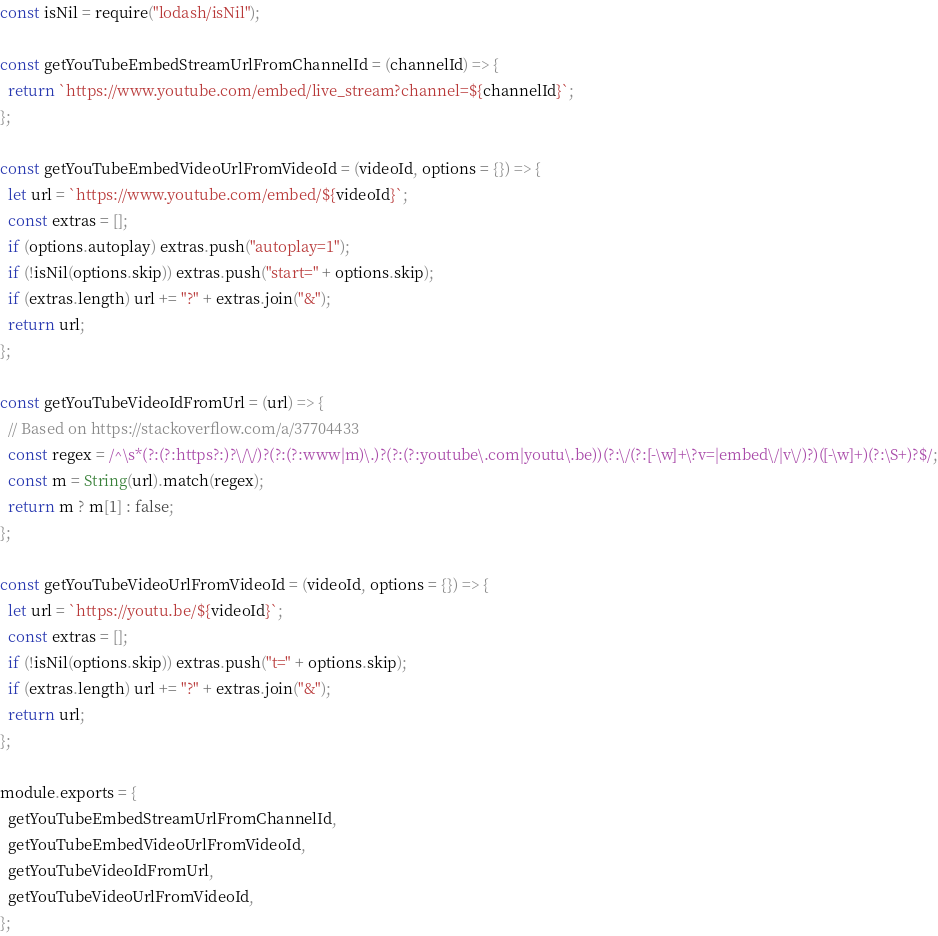<code> <loc_0><loc_0><loc_500><loc_500><_JavaScript_>const isNil = require("lodash/isNil");

const getYouTubeEmbedStreamUrlFromChannelId = (channelId) => {
  return `https://www.youtube.com/embed/live_stream?channel=${channelId}`;
};

const getYouTubeEmbedVideoUrlFromVideoId = (videoId, options = {}) => {
  let url = `https://www.youtube.com/embed/${videoId}`;
  const extras = [];
  if (options.autoplay) extras.push("autoplay=1");
  if (!isNil(options.skip)) extras.push("start=" + options.skip);
  if (extras.length) url += "?" + extras.join("&");
  return url;
};

const getYouTubeVideoIdFromUrl = (url) => {
  // Based on https://stackoverflow.com/a/37704433
  const regex = /^\s*(?:(?:https?:)?\/\/)?(?:(?:www|m)\.)?(?:(?:youtube\.com|youtu\.be))(?:\/(?:[-\w]+\?v=|embed\/|v\/)?)([-\w]+)(?:\S+)?$/;
  const m = String(url).match(regex);
  return m ? m[1] : false;
};

const getYouTubeVideoUrlFromVideoId = (videoId, options = {}) => {
  let url = `https://youtu.be/${videoId}`;
  const extras = [];
  if (!isNil(options.skip)) extras.push("t=" + options.skip);
  if (extras.length) url += "?" + extras.join("&");
  return url;
};

module.exports = {
  getYouTubeEmbedStreamUrlFromChannelId,
  getYouTubeEmbedVideoUrlFromVideoId,
  getYouTubeVideoIdFromUrl,
  getYouTubeVideoUrlFromVideoId,
};
</code> 